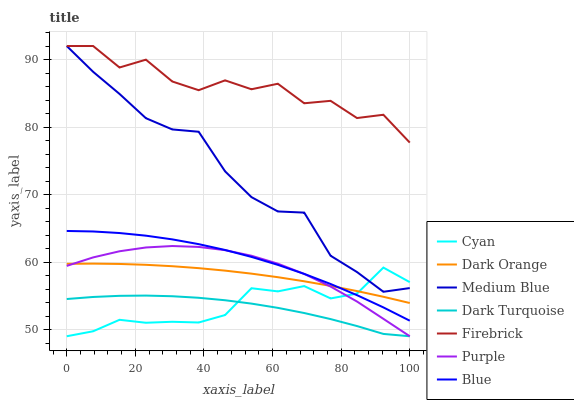Does Dark Turquoise have the minimum area under the curve?
Answer yes or no. Yes. Does Firebrick have the maximum area under the curve?
Answer yes or no. Yes. Does Dark Orange have the minimum area under the curve?
Answer yes or no. No. Does Dark Orange have the maximum area under the curve?
Answer yes or no. No. Is Dark Orange the smoothest?
Answer yes or no. Yes. Is Firebrick the roughest?
Answer yes or no. Yes. Is Purple the smoothest?
Answer yes or no. No. Is Purple the roughest?
Answer yes or no. No. Does Purple have the lowest value?
Answer yes or no. Yes. Does Dark Orange have the lowest value?
Answer yes or no. No. Does Medium Blue have the highest value?
Answer yes or no. Yes. Does Dark Orange have the highest value?
Answer yes or no. No. Is Purple less than Firebrick?
Answer yes or no. Yes. Is Firebrick greater than Blue?
Answer yes or no. Yes. Does Firebrick intersect Medium Blue?
Answer yes or no. Yes. Is Firebrick less than Medium Blue?
Answer yes or no. No. Is Firebrick greater than Medium Blue?
Answer yes or no. No. Does Purple intersect Firebrick?
Answer yes or no. No. 